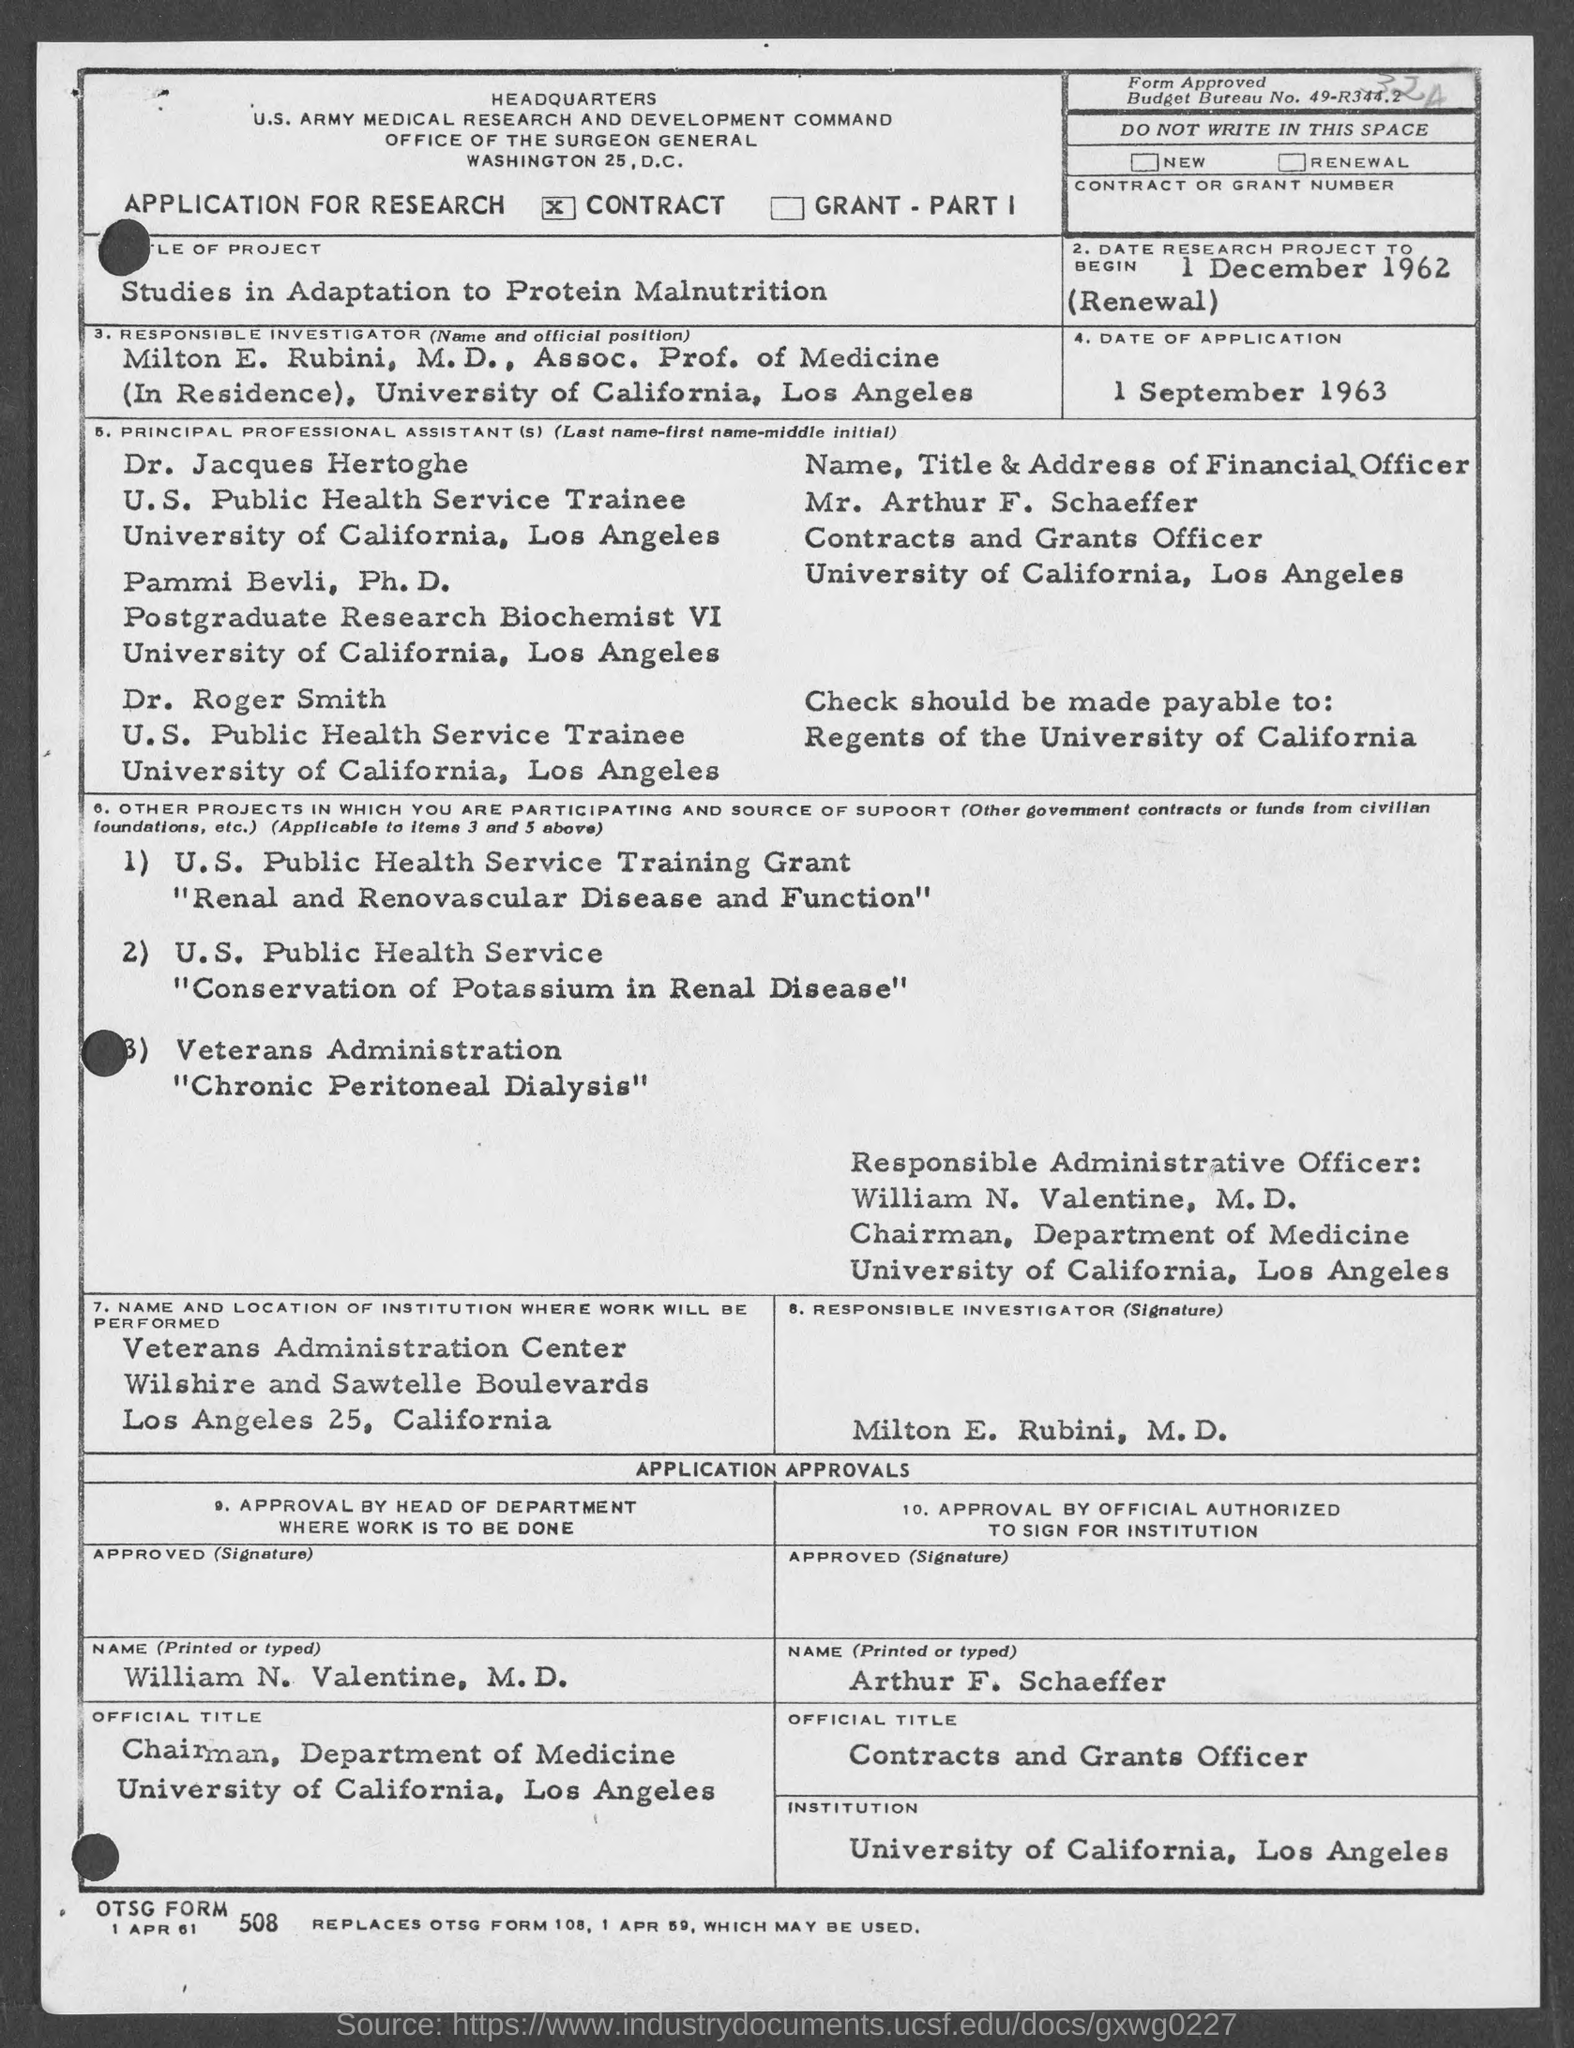Mention a couple of crucial points in this snapshot. The check should be made payable to 'Regents of the University of California.' The project listed is the Veterans Administration's Chronic Peritoneal Dialysis. Milton holds the position of Associate Professor of Medicine, currently serving in residence. Milton E. Rubini, M.D. is the responsible investigator. The date of application is September 1, 1963. 